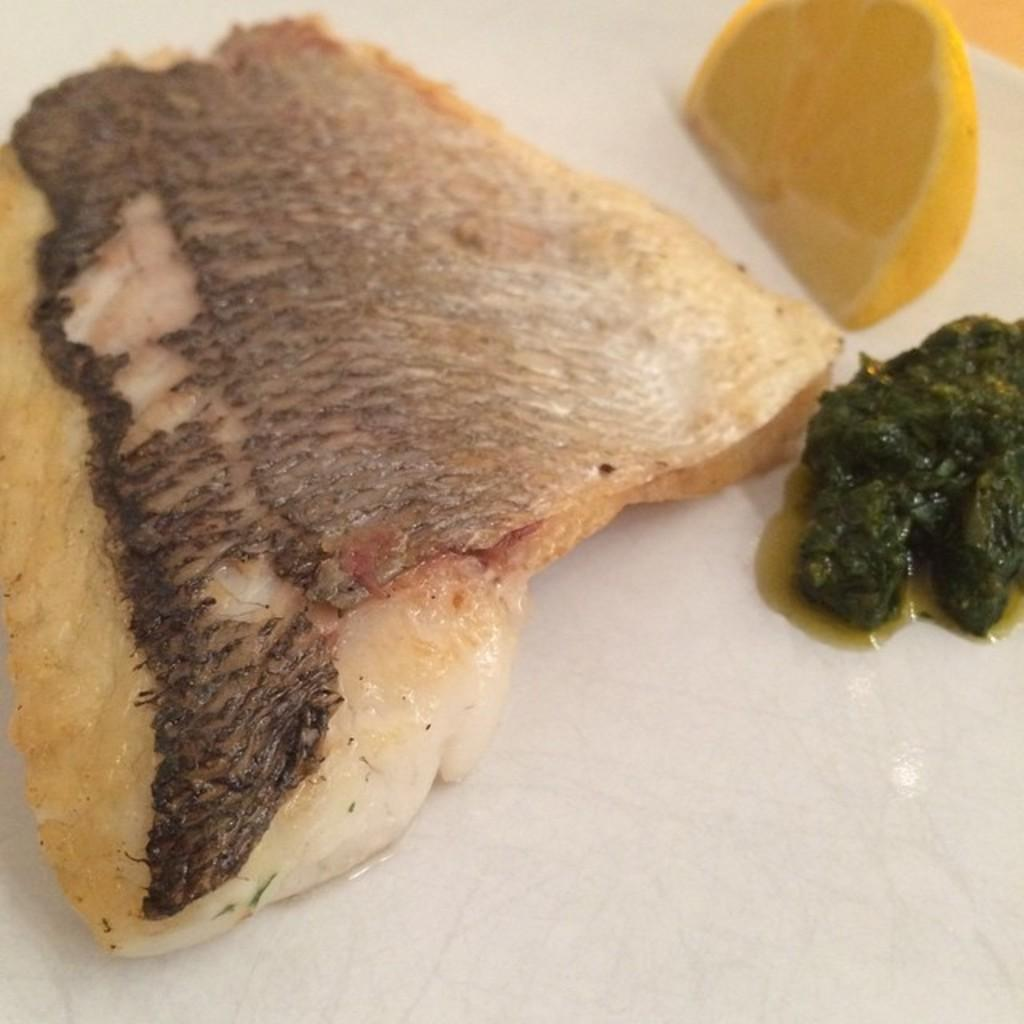What types of food items can be seen in the image? There are food items in the image, but their specific types cannot be determined from the provided facts. What is the shape of the lemon slice in the image? The shape of the lemon slice cannot be determined from the provided facts. What is the color of the surface on which the food items and lemon slice are placed? The surface is white. Can you hear the ear in the image? There is no ear present in the image, so it cannot be heard. 